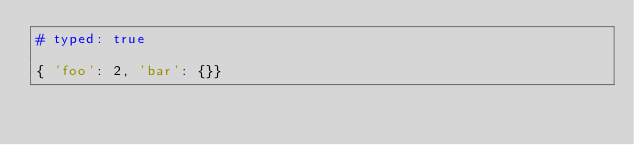<code> <loc_0><loc_0><loc_500><loc_500><_Ruby_># typed: true

{ 'foo': 2, 'bar': {}}
</code> 